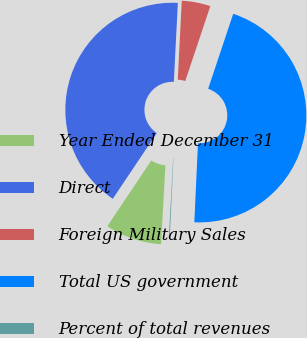Convert chart to OTSL. <chart><loc_0><loc_0><loc_500><loc_500><pie_chart><fcel>Year Ended December 31<fcel>Direct<fcel>Foreign Military Sales<fcel>Total US government<fcel>Percent of total revenues<nl><fcel>8.52%<fcel>41.41%<fcel>4.33%<fcel>45.6%<fcel>0.14%<nl></chart> 